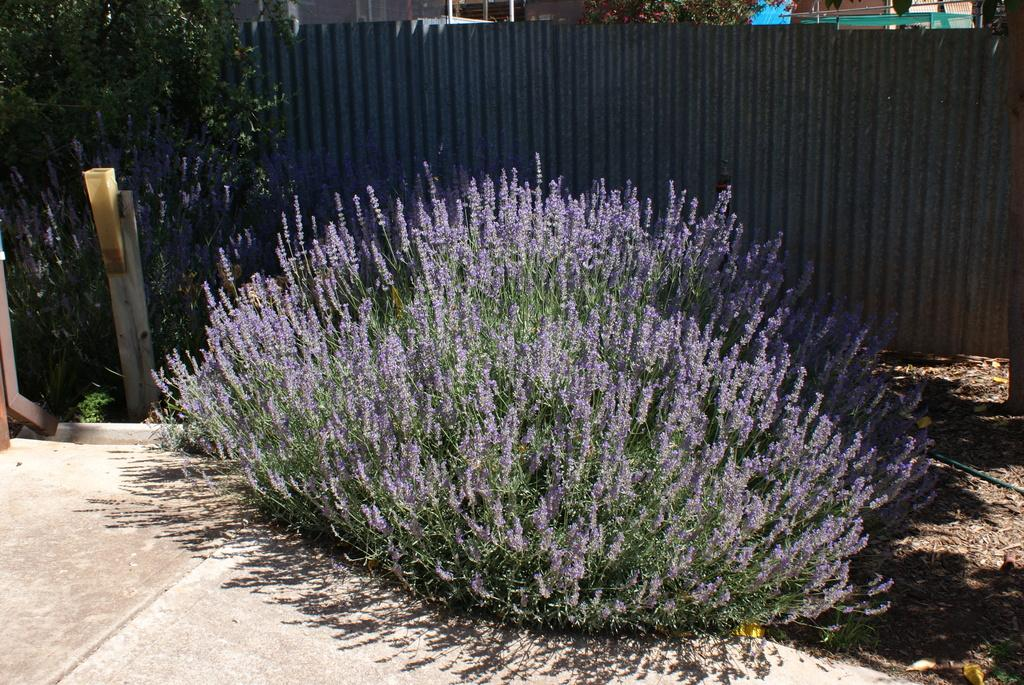What type of plant is visible in the image? There is a plant with flowers in the image. What other vegetation can be seen in the image? There is a tree on the side of the image. What type of barrier is present in the image? There is a metal fence in the image. What type of structures are visible in the image? There are buildings visible in the image. What type of cracker is being used to decorate the plant in the image? There is no cracker present in the image, and the plant is not being decorated. What color are the lips of the person in the image? There is no person present in the image, so we cannot determine the color of their lips. 